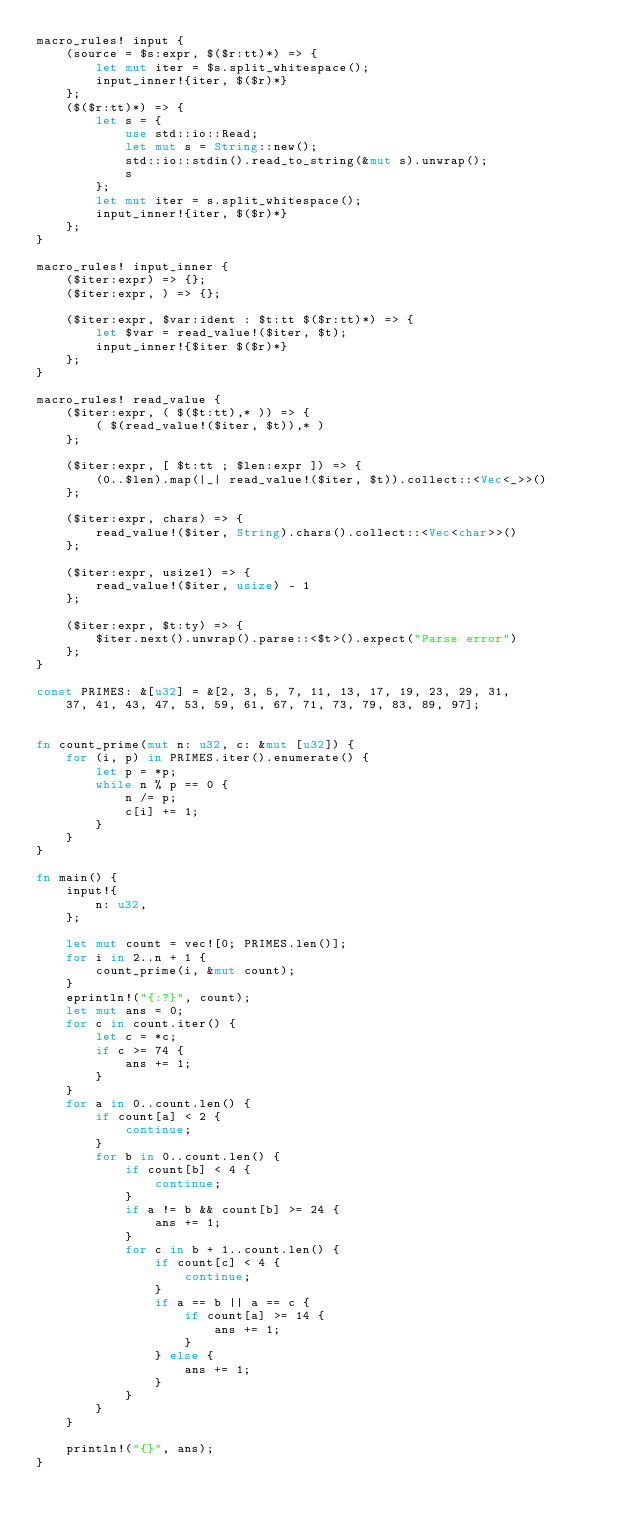<code> <loc_0><loc_0><loc_500><loc_500><_Rust_>macro_rules! input {
    (source = $s:expr, $($r:tt)*) => {
        let mut iter = $s.split_whitespace();
        input_inner!{iter, $($r)*}
    };
    ($($r:tt)*) => {
        let s = {
            use std::io::Read;
            let mut s = String::new();
            std::io::stdin().read_to_string(&mut s).unwrap();
            s
        };
        let mut iter = s.split_whitespace();
        input_inner!{iter, $($r)*}
    };
}

macro_rules! input_inner {
    ($iter:expr) => {};
    ($iter:expr, ) => {};

    ($iter:expr, $var:ident : $t:tt $($r:tt)*) => {
        let $var = read_value!($iter, $t);
        input_inner!{$iter $($r)*}
    };
}

macro_rules! read_value {
    ($iter:expr, ( $($t:tt),* )) => {
        ( $(read_value!($iter, $t)),* )
    };

    ($iter:expr, [ $t:tt ; $len:expr ]) => {
        (0..$len).map(|_| read_value!($iter, $t)).collect::<Vec<_>>()
    };

    ($iter:expr, chars) => {
        read_value!($iter, String).chars().collect::<Vec<char>>()
    };

    ($iter:expr, usize1) => {
        read_value!($iter, usize) - 1
    };

    ($iter:expr, $t:ty) => {
        $iter.next().unwrap().parse::<$t>().expect("Parse error")
    };
}

const PRIMES: &[u32] = &[2, 3, 5, 7, 11, 13, 17, 19, 23, 29, 31,
    37, 41, 43, 47, 53, 59, 61, 67, 71, 73, 79, 83, 89, 97];


fn count_prime(mut n: u32, c: &mut [u32]) {
    for (i, p) in PRIMES.iter().enumerate() {
        let p = *p;
        while n % p == 0 {
            n /= p;
            c[i] += 1;
        }
    }
}

fn main() {
    input!{
        n: u32,
    };

    let mut count = vec![0; PRIMES.len()];
    for i in 2..n + 1 {
        count_prime(i, &mut count);
    }
    eprintln!("{:?}", count);
    let mut ans = 0;
    for c in count.iter() {
        let c = *c;
        if c >= 74 {
            ans += 1;
        }
    }
    for a in 0..count.len() {
        if count[a] < 2 {
            continue;
        }
        for b in 0..count.len() {
            if count[b] < 4 {
                continue;
            }
            if a != b && count[b] >= 24 {
                ans += 1;
            }
            for c in b + 1..count.len() {
                if count[c] < 4 {
                    continue;
                }
                if a == b || a == c {
                    if count[a] >= 14 {
                        ans += 1;
                    }
                } else {
                    ans += 1;
                }
            }
        }
    }
    
    println!("{}", ans);
}
</code> 